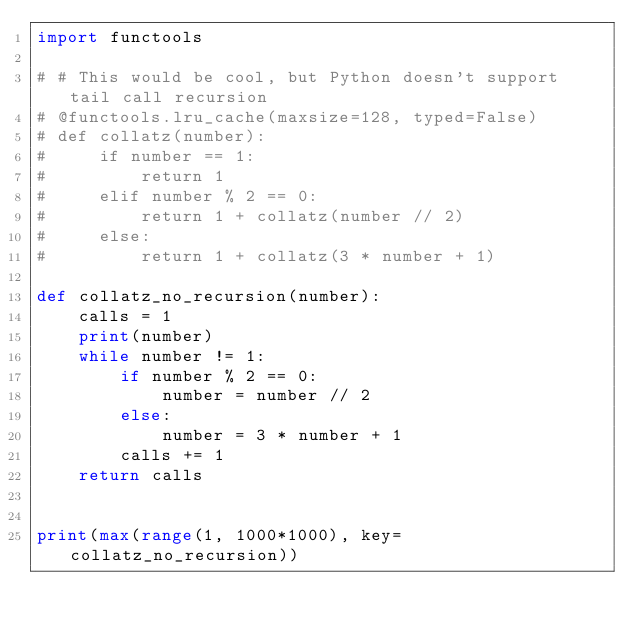<code> <loc_0><loc_0><loc_500><loc_500><_Python_>import functools

# # This would be cool, but Python doesn't support tail call recursion
# @functools.lru_cache(maxsize=128, typed=False)
# def collatz(number):
#     if number == 1:
#         return 1
#     elif number % 2 == 0:
#         return 1 + collatz(number // 2)
#     else:
#         return 1 + collatz(3 * number + 1)

def collatz_no_recursion(number):
    calls = 1
    print(number)
    while number != 1:
        if number % 2 == 0:
            number = number // 2
        else:
            number = 3 * number + 1
        calls += 1
    return calls


print(max(range(1, 1000*1000), key=collatz_no_recursion))
</code> 